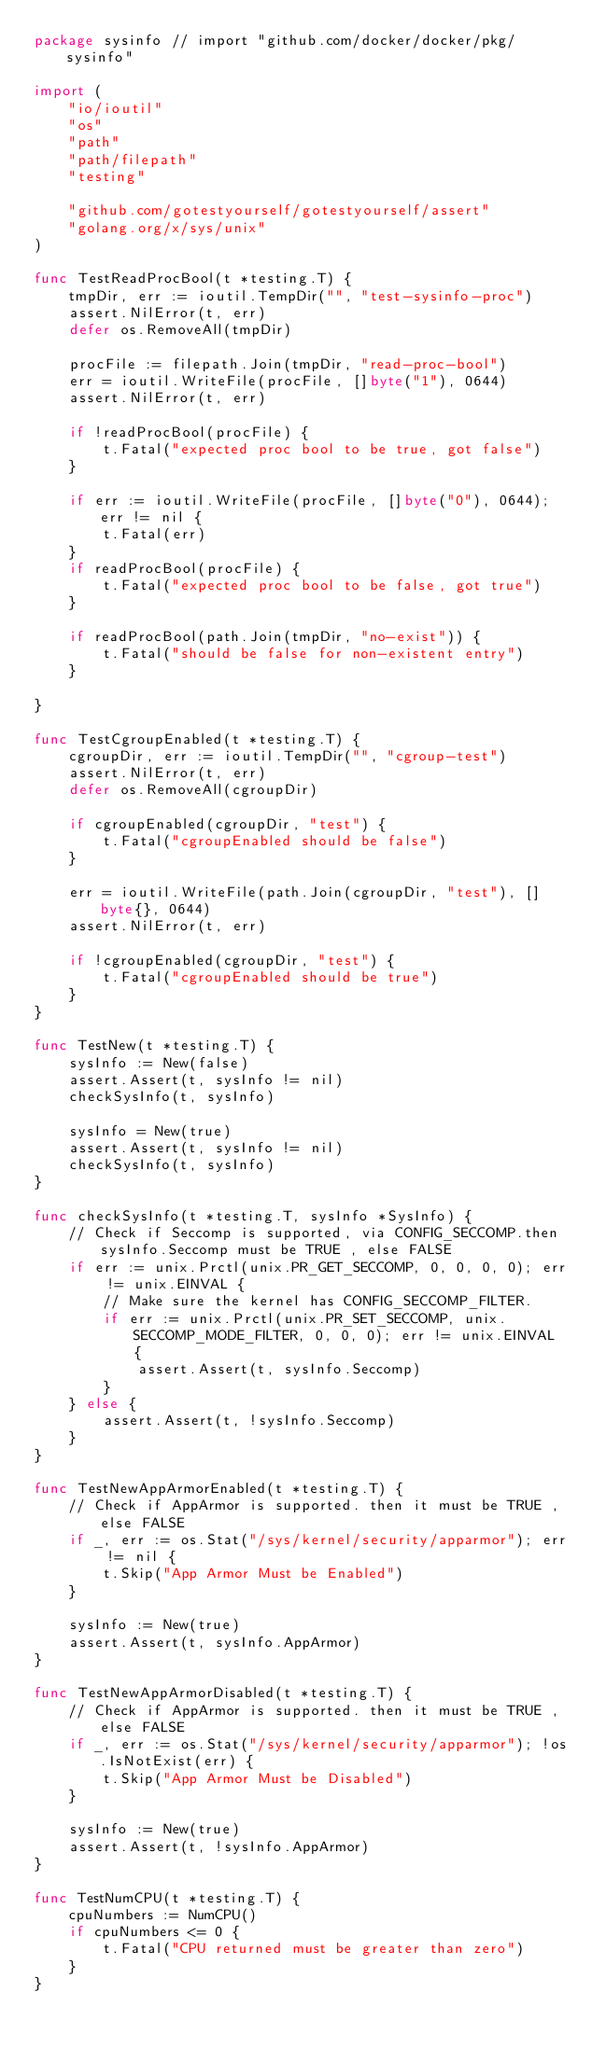<code> <loc_0><loc_0><loc_500><loc_500><_Go_>package sysinfo // import "github.com/docker/docker/pkg/sysinfo"

import (
	"io/ioutil"
	"os"
	"path"
	"path/filepath"
	"testing"

	"github.com/gotestyourself/gotestyourself/assert"
	"golang.org/x/sys/unix"
)

func TestReadProcBool(t *testing.T) {
	tmpDir, err := ioutil.TempDir("", "test-sysinfo-proc")
	assert.NilError(t, err)
	defer os.RemoveAll(tmpDir)

	procFile := filepath.Join(tmpDir, "read-proc-bool")
	err = ioutil.WriteFile(procFile, []byte("1"), 0644)
	assert.NilError(t, err)

	if !readProcBool(procFile) {
		t.Fatal("expected proc bool to be true, got false")
	}

	if err := ioutil.WriteFile(procFile, []byte("0"), 0644); err != nil {
		t.Fatal(err)
	}
	if readProcBool(procFile) {
		t.Fatal("expected proc bool to be false, got true")
	}

	if readProcBool(path.Join(tmpDir, "no-exist")) {
		t.Fatal("should be false for non-existent entry")
	}

}

func TestCgroupEnabled(t *testing.T) {
	cgroupDir, err := ioutil.TempDir("", "cgroup-test")
	assert.NilError(t, err)
	defer os.RemoveAll(cgroupDir)

	if cgroupEnabled(cgroupDir, "test") {
		t.Fatal("cgroupEnabled should be false")
	}

	err = ioutil.WriteFile(path.Join(cgroupDir, "test"), []byte{}, 0644)
	assert.NilError(t, err)

	if !cgroupEnabled(cgroupDir, "test") {
		t.Fatal("cgroupEnabled should be true")
	}
}

func TestNew(t *testing.T) {
	sysInfo := New(false)
	assert.Assert(t, sysInfo != nil)
	checkSysInfo(t, sysInfo)

	sysInfo = New(true)
	assert.Assert(t, sysInfo != nil)
	checkSysInfo(t, sysInfo)
}

func checkSysInfo(t *testing.T, sysInfo *SysInfo) {
	// Check if Seccomp is supported, via CONFIG_SECCOMP.then sysInfo.Seccomp must be TRUE , else FALSE
	if err := unix.Prctl(unix.PR_GET_SECCOMP, 0, 0, 0, 0); err != unix.EINVAL {
		// Make sure the kernel has CONFIG_SECCOMP_FILTER.
		if err := unix.Prctl(unix.PR_SET_SECCOMP, unix.SECCOMP_MODE_FILTER, 0, 0, 0); err != unix.EINVAL {
			assert.Assert(t, sysInfo.Seccomp)
		}
	} else {
		assert.Assert(t, !sysInfo.Seccomp)
	}
}

func TestNewAppArmorEnabled(t *testing.T) {
	// Check if AppArmor is supported. then it must be TRUE , else FALSE
	if _, err := os.Stat("/sys/kernel/security/apparmor"); err != nil {
		t.Skip("App Armor Must be Enabled")
	}

	sysInfo := New(true)
	assert.Assert(t, sysInfo.AppArmor)
}

func TestNewAppArmorDisabled(t *testing.T) {
	// Check if AppArmor is supported. then it must be TRUE , else FALSE
	if _, err := os.Stat("/sys/kernel/security/apparmor"); !os.IsNotExist(err) {
		t.Skip("App Armor Must be Disabled")
	}

	sysInfo := New(true)
	assert.Assert(t, !sysInfo.AppArmor)
}

func TestNumCPU(t *testing.T) {
	cpuNumbers := NumCPU()
	if cpuNumbers <= 0 {
		t.Fatal("CPU returned must be greater than zero")
	}
}
</code> 